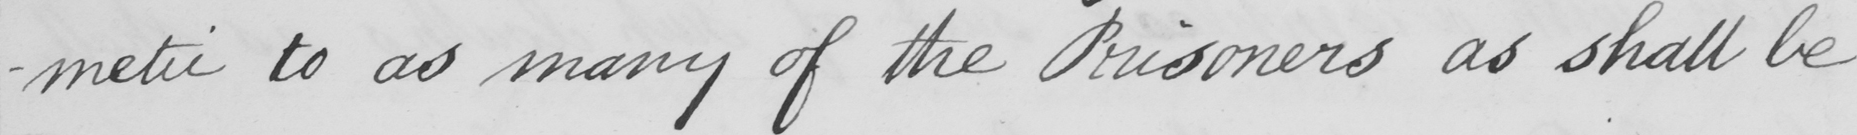Transcribe the text shown in this historical manuscript line. -metic to as many of the Prisoners as shall be 